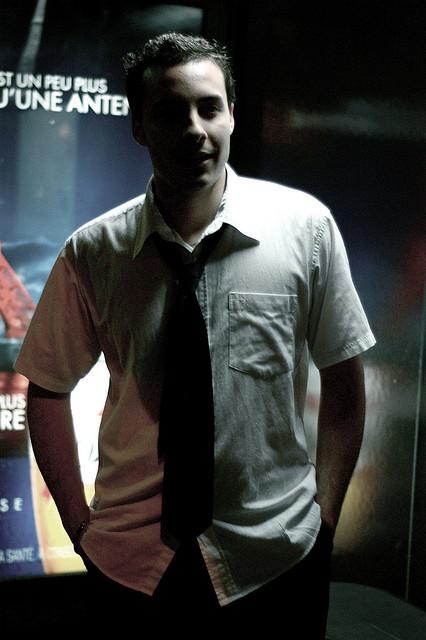Where are this man's hands?
Answer briefly. Pockets. Does the man's shirt have a pocket?
Keep it brief. Yes. How many buttons are on the shirt?
Give a very brief answer. 7. 